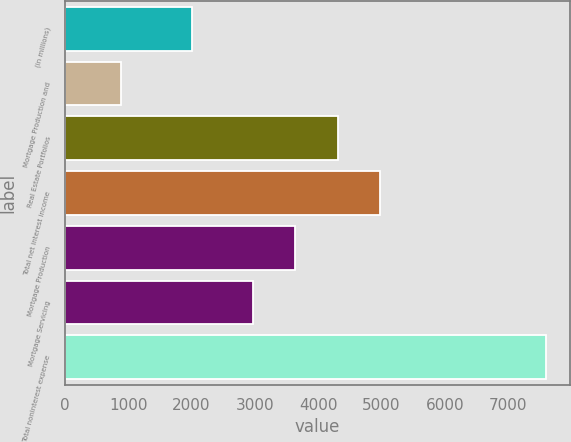<chart> <loc_0><loc_0><loc_500><loc_500><bar_chart><fcel>(in millions)<fcel>Mortgage Production and<fcel>Real Estate Portfolios<fcel>Total net interest income<fcel>Mortgage Production<fcel>Mortgage Servicing<fcel>Total noninterest expense<nl><fcel>2013<fcel>887<fcel>4309<fcel>4980.5<fcel>3637.5<fcel>2966<fcel>7602<nl></chart> 